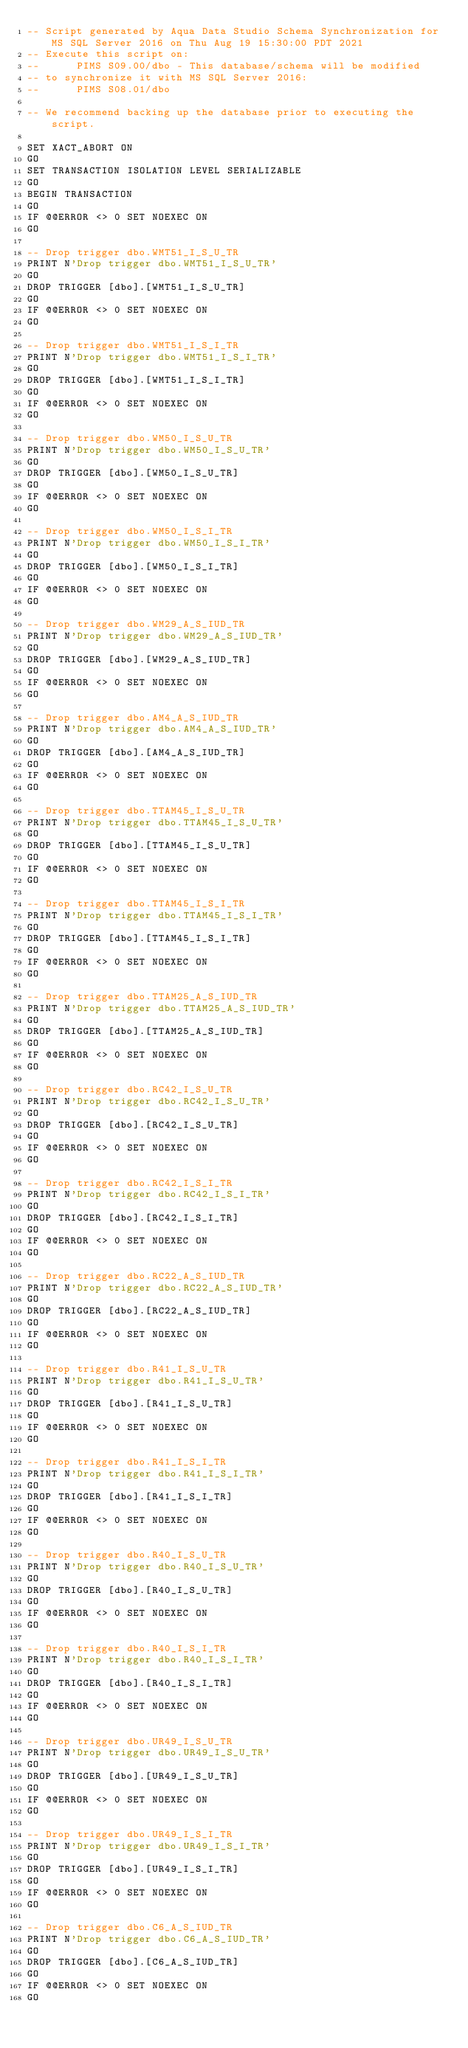<code> <loc_0><loc_0><loc_500><loc_500><_SQL_>-- Script generated by Aqua Data Studio Schema Synchronization for MS SQL Server 2016 on Thu Aug 19 15:30:00 PDT 2021
-- Execute this script on:
-- 		PIMS S09.00/dbo - This database/schema will be modified
-- to synchronize it with MS SQL Server 2016:
-- 		PIMS S08.01/dbo

-- We recommend backing up the database prior to executing the script.

SET XACT_ABORT ON
GO
SET TRANSACTION ISOLATION LEVEL SERIALIZABLE
GO
BEGIN TRANSACTION
GO
IF @@ERROR <> 0 SET NOEXEC ON
GO

-- Drop trigger dbo.WMT51_I_S_U_TR
PRINT N'Drop trigger dbo.WMT51_I_S_U_TR'
GO
DROP TRIGGER [dbo].[WMT51_I_S_U_TR]
GO
IF @@ERROR <> 0 SET NOEXEC ON
GO

-- Drop trigger dbo.WMT51_I_S_I_TR
PRINT N'Drop trigger dbo.WMT51_I_S_I_TR'
GO
DROP TRIGGER [dbo].[WMT51_I_S_I_TR]
GO
IF @@ERROR <> 0 SET NOEXEC ON
GO

-- Drop trigger dbo.WM50_I_S_U_TR
PRINT N'Drop trigger dbo.WM50_I_S_U_TR'
GO
DROP TRIGGER [dbo].[WM50_I_S_U_TR]
GO
IF @@ERROR <> 0 SET NOEXEC ON
GO

-- Drop trigger dbo.WM50_I_S_I_TR
PRINT N'Drop trigger dbo.WM50_I_S_I_TR'
GO
DROP TRIGGER [dbo].[WM50_I_S_I_TR]
GO
IF @@ERROR <> 0 SET NOEXEC ON
GO

-- Drop trigger dbo.WM29_A_S_IUD_TR
PRINT N'Drop trigger dbo.WM29_A_S_IUD_TR'
GO
DROP TRIGGER [dbo].[WM29_A_S_IUD_TR]
GO
IF @@ERROR <> 0 SET NOEXEC ON
GO

-- Drop trigger dbo.AM4_A_S_IUD_TR
PRINT N'Drop trigger dbo.AM4_A_S_IUD_TR'
GO
DROP TRIGGER [dbo].[AM4_A_S_IUD_TR]
GO
IF @@ERROR <> 0 SET NOEXEC ON
GO

-- Drop trigger dbo.TTAM45_I_S_U_TR
PRINT N'Drop trigger dbo.TTAM45_I_S_U_TR'
GO
DROP TRIGGER [dbo].[TTAM45_I_S_U_TR]
GO
IF @@ERROR <> 0 SET NOEXEC ON
GO

-- Drop trigger dbo.TTAM45_I_S_I_TR
PRINT N'Drop trigger dbo.TTAM45_I_S_I_TR'
GO
DROP TRIGGER [dbo].[TTAM45_I_S_I_TR]
GO
IF @@ERROR <> 0 SET NOEXEC ON
GO

-- Drop trigger dbo.TTAM25_A_S_IUD_TR
PRINT N'Drop trigger dbo.TTAM25_A_S_IUD_TR'
GO
DROP TRIGGER [dbo].[TTAM25_A_S_IUD_TR]
GO
IF @@ERROR <> 0 SET NOEXEC ON
GO

-- Drop trigger dbo.RC42_I_S_U_TR
PRINT N'Drop trigger dbo.RC42_I_S_U_TR'
GO
DROP TRIGGER [dbo].[RC42_I_S_U_TR]
GO
IF @@ERROR <> 0 SET NOEXEC ON
GO

-- Drop trigger dbo.RC42_I_S_I_TR
PRINT N'Drop trigger dbo.RC42_I_S_I_TR'
GO
DROP TRIGGER [dbo].[RC42_I_S_I_TR]
GO
IF @@ERROR <> 0 SET NOEXEC ON
GO

-- Drop trigger dbo.RC22_A_S_IUD_TR
PRINT N'Drop trigger dbo.RC22_A_S_IUD_TR'
GO
DROP TRIGGER [dbo].[RC22_A_S_IUD_TR]
GO
IF @@ERROR <> 0 SET NOEXEC ON
GO

-- Drop trigger dbo.R41_I_S_U_TR
PRINT N'Drop trigger dbo.R41_I_S_U_TR'
GO
DROP TRIGGER [dbo].[R41_I_S_U_TR]
GO
IF @@ERROR <> 0 SET NOEXEC ON
GO

-- Drop trigger dbo.R41_I_S_I_TR
PRINT N'Drop trigger dbo.R41_I_S_I_TR'
GO
DROP TRIGGER [dbo].[R41_I_S_I_TR]
GO
IF @@ERROR <> 0 SET NOEXEC ON
GO

-- Drop trigger dbo.R40_I_S_U_TR
PRINT N'Drop trigger dbo.R40_I_S_U_TR'
GO
DROP TRIGGER [dbo].[R40_I_S_U_TR]
GO
IF @@ERROR <> 0 SET NOEXEC ON
GO

-- Drop trigger dbo.R40_I_S_I_TR
PRINT N'Drop trigger dbo.R40_I_S_I_TR'
GO
DROP TRIGGER [dbo].[R40_I_S_I_TR]
GO
IF @@ERROR <> 0 SET NOEXEC ON
GO

-- Drop trigger dbo.UR49_I_S_U_TR
PRINT N'Drop trigger dbo.UR49_I_S_U_TR'
GO
DROP TRIGGER [dbo].[UR49_I_S_U_TR]
GO
IF @@ERROR <> 0 SET NOEXEC ON
GO

-- Drop trigger dbo.UR49_I_S_I_TR
PRINT N'Drop trigger dbo.UR49_I_S_I_TR'
GO
DROP TRIGGER [dbo].[UR49_I_S_I_TR]
GO
IF @@ERROR <> 0 SET NOEXEC ON
GO

-- Drop trigger dbo.C6_A_S_IUD_TR
PRINT N'Drop trigger dbo.C6_A_S_IUD_TR'
GO
DROP TRIGGER [dbo].[C6_A_S_IUD_TR]
GO
IF @@ERROR <> 0 SET NOEXEC ON
GO
</code> 